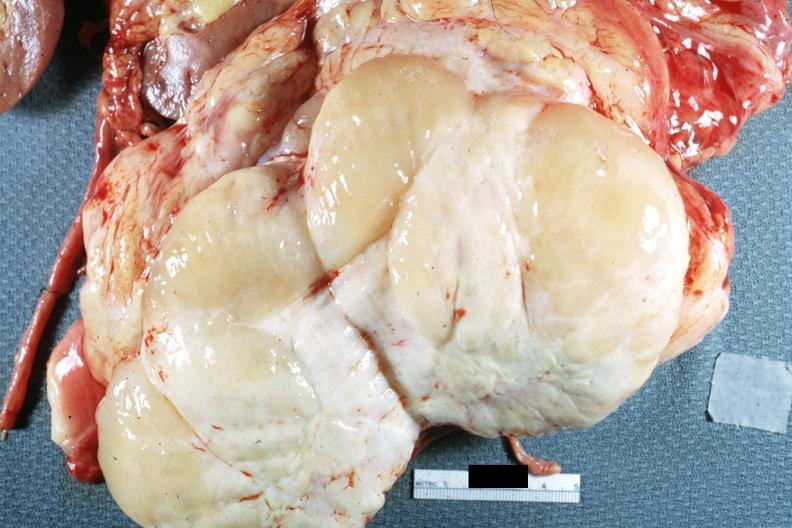s abdomen present?
Answer the question using a single word or phrase. Yes 